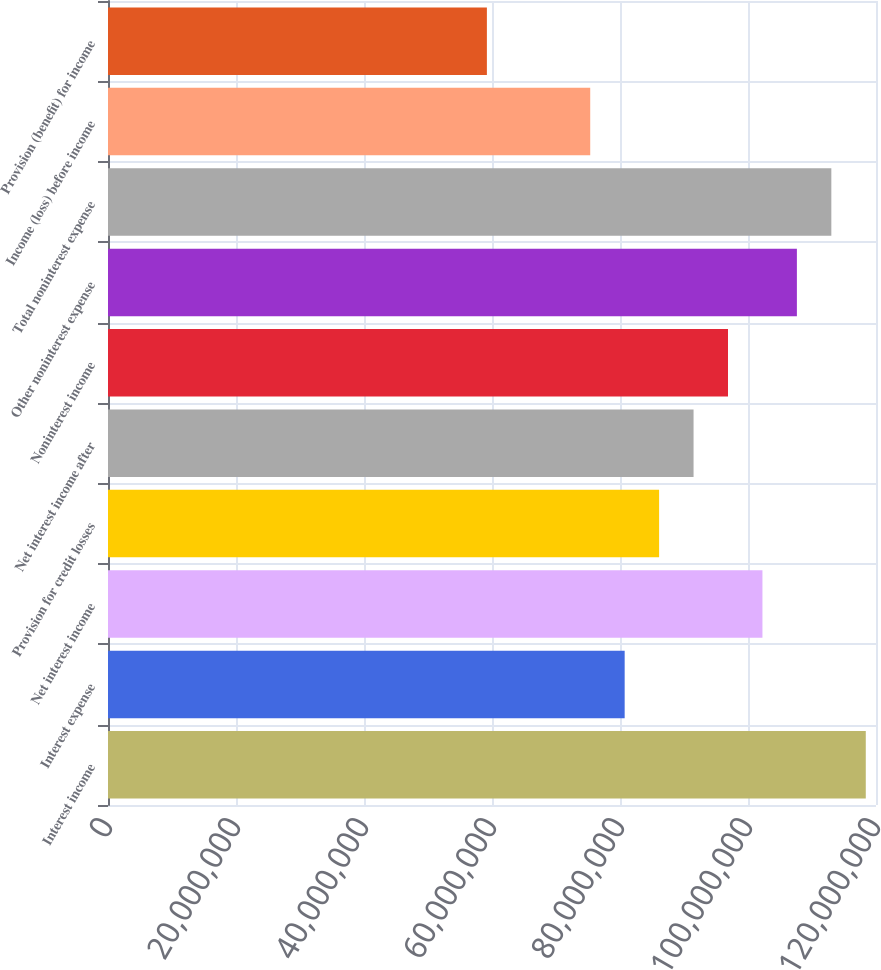<chart> <loc_0><loc_0><loc_500><loc_500><bar_chart><fcel>Interest income<fcel>Interest expense<fcel>Net interest income<fcel>Provision for credit losses<fcel>Net interest income after<fcel>Noninterest income<fcel>Other noninterest expense<fcel>Total noninterest expense<fcel>Income (loss) before income<fcel>Provision (benefit) for income<nl><fcel>1.18403e+08<fcel>8.07295e+07<fcel>1.02257e+08<fcel>8.61114e+07<fcel>9.14934e+07<fcel>9.68754e+07<fcel>1.07639e+08<fcel>1.13021e+08<fcel>7.53475e+07<fcel>5.92016e+07<nl></chart> 